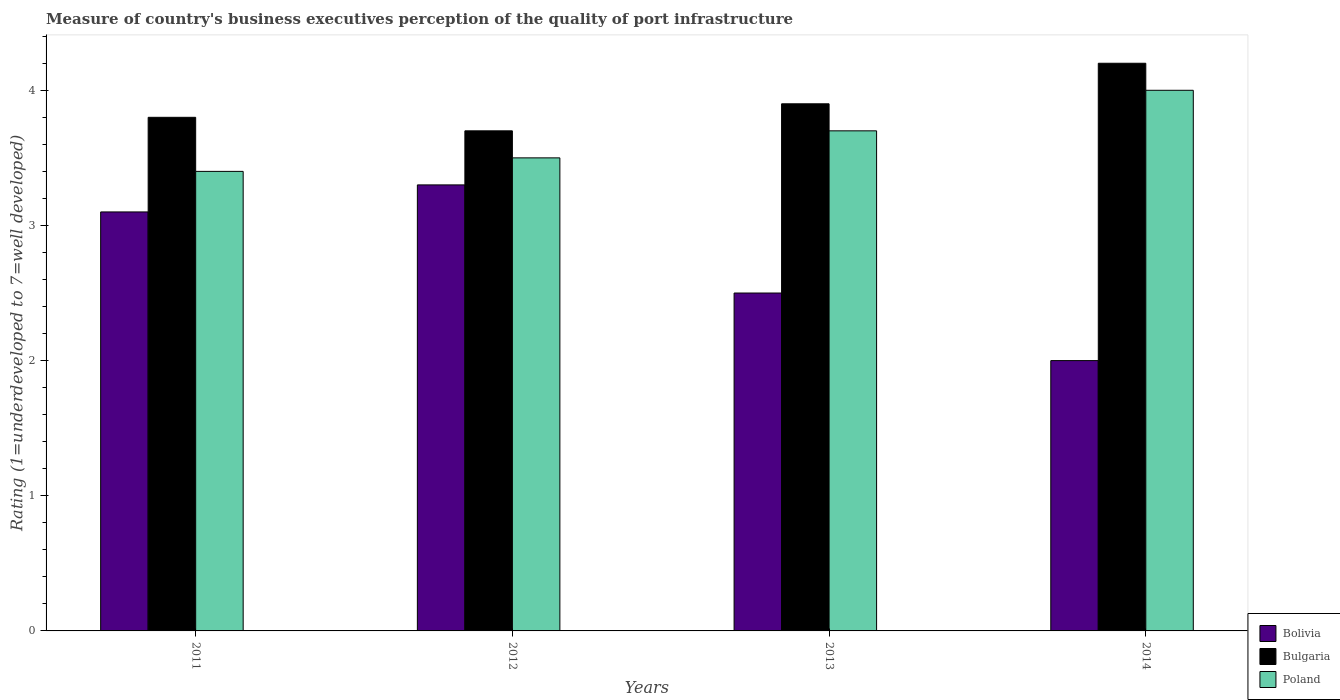How many different coloured bars are there?
Your answer should be compact. 3. In how many cases, is the number of bars for a given year not equal to the number of legend labels?
Offer a very short reply. 0. What is the ratings of the quality of port infrastructure in Bolivia in 2011?
Your answer should be compact. 3.1. Across all years, what is the maximum ratings of the quality of port infrastructure in Poland?
Your response must be concise. 4. Across all years, what is the minimum ratings of the quality of port infrastructure in Bulgaria?
Provide a short and direct response. 3.7. In which year was the ratings of the quality of port infrastructure in Poland maximum?
Offer a very short reply. 2014. What is the difference between the ratings of the quality of port infrastructure in Poland in 2012 and that in 2013?
Your response must be concise. -0.2. What is the difference between the ratings of the quality of port infrastructure in Bolivia in 2011 and the ratings of the quality of port infrastructure in Poland in 2014?
Your answer should be very brief. -0.9. What is the average ratings of the quality of port infrastructure in Bulgaria per year?
Provide a short and direct response. 3.9. In the year 2011, what is the difference between the ratings of the quality of port infrastructure in Bulgaria and ratings of the quality of port infrastructure in Poland?
Make the answer very short. 0.4. What is the difference between the highest and the second highest ratings of the quality of port infrastructure in Poland?
Your answer should be compact. 0.3. What is the difference between the highest and the lowest ratings of the quality of port infrastructure in Bolivia?
Your answer should be compact. 1.3. Is the sum of the ratings of the quality of port infrastructure in Bulgaria in 2012 and 2013 greater than the maximum ratings of the quality of port infrastructure in Poland across all years?
Ensure brevity in your answer.  Yes. What does the 2nd bar from the right in 2012 represents?
Make the answer very short. Bulgaria. Is it the case that in every year, the sum of the ratings of the quality of port infrastructure in Bolivia and ratings of the quality of port infrastructure in Bulgaria is greater than the ratings of the quality of port infrastructure in Poland?
Offer a very short reply. Yes. Are all the bars in the graph horizontal?
Give a very brief answer. No. How many years are there in the graph?
Offer a terse response. 4. What is the difference between two consecutive major ticks on the Y-axis?
Offer a very short reply. 1. How are the legend labels stacked?
Offer a terse response. Vertical. What is the title of the graph?
Your response must be concise. Measure of country's business executives perception of the quality of port infrastructure. What is the label or title of the X-axis?
Ensure brevity in your answer.  Years. What is the label or title of the Y-axis?
Ensure brevity in your answer.  Rating (1=underdeveloped to 7=well developed). What is the Rating (1=underdeveloped to 7=well developed) of Bolivia in 2011?
Your answer should be compact. 3.1. What is the Rating (1=underdeveloped to 7=well developed) in Bulgaria in 2011?
Make the answer very short. 3.8. What is the Rating (1=underdeveloped to 7=well developed) in Poland in 2012?
Your answer should be compact. 3.5. What is the Rating (1=underdeveloped to 7=well developed) in Bolivia in 2014?
Your answer should be very brief. 2. Across all years, what is the maximum Rating (1=underdeveloped to 7=well developed) in Bulgaria?
Provide a succinct answer. 4.2. Across all years, what is the maximum Rating (1=underdeveloped to 7=well developed) in Poland?
Keep it short and to the point. 4. Across all years, what is the minimum Rating (1=underdeveloped to 7=well developed) of Bolivia?
Make the answer very short. 2. Across all years, what is the minimum Rating (1=underdeveloped to 7=well developed) of Bulgaria?
Keep it short and to the point. 3.7. Across all years, what is the minimum Rating (1=underdeveloped to 7=well developed) of Poland?
Your response must be concise. 3.4. What is the total Rating (1=underdeveloped to 7=well developed) of Bolivia in the graph?
Your response must be concise. 10.9. What is the total Rating (1=underdeveloped to 7=well developed) in Poland in the graph?
Offer a terse response. 14.6. What is the difference between the Rating (1=underdeveloped to 7=well developed) of Bulgaria in 2011 and that in 2012?
Offer a very short reply. 0.1. What is the difference between the Rating (1=underdeveloped to 7=well developed) in Poland in 2011 and that in 2012?
Your answer should be very brief. -0.1. What is the difference between the Rating (1=underdeveloped to 7=well developed) of Bolivia in 2011 and that in 2013?
Your answer should be very brief. 0.6. What is the difference between the Rating (1=underdeveloped to 7=well developed) in Bolivia in 2011 and that in 2014?
Give a very brief answer. 1.1. What is the difference between the Rating (1=underdeveloped to 7=well developed) of Bulgaria in 2011 and that in 2014?
Make the answer very short. -0.4. What is the difference between the Rating (1=underdeveloped to 7=well developed) in Poland in 2012 and that in 2013?
Give a very brief answer. -0.2. What is the difference between the Rating (1=underdeveloped to 7=well developed) of Bolivia in 2012 and that in 2014?
Ensure brevity in your answer.  1.3. What is the difference between the Rating (1=underdeveloped to 7=well developed) of Poland in 2012 and that in 2014?
Offer a very short reply. -0.5. What is the difference between the Rating (1=underdeveloped to 7=well developed) of Bolivia in 2013 and that in 2014?
Provide a short and direct response. 0.5. What is the difference between the Rating (1=underdeveloped to 7=well developed) in Bulgaria in 2013 and that in 2014?
Give a very brief answer. -0.3. What is the difference between the Rating (1=underdeveloped to 7=well developed) in Bolivia in 2011 and the Rating (1=underdeveloped to 7=well developed) in Bulgaria in 2012?
Give a very brief answer. -0.6. What is the difference between the Rating (1=underdeveloped to 7=well developed) in Bolivia in 2011 and the Rating (1=underdeveloped to 7=well developed) in Poland in 2012?
Offer a terse response. -0.4. What is the difference between the Rating (1=underdeveloped to 7=well developed) in Bulgaria in 2011 and the Rating (1=underdeveloped to 7=well developed) in Poland in 2012?
Your response must be concise. 0.3. What is the difference between the Rating (1=underdeveloped to 7=well developed) of Bulgaria in 2011 and the Rating (1=underdeveloped to 7=well developed) of Poland in 2013?
Provide a short and direct response. 0.1. What is the difference between the Rating (1=underdeveloped to 7=well developed) of Bolivia in 2011 and the Rating (1=underdeveloped to 7=well developed) of Poland in 2014?
Your answer should be very brief. -0.9. What is the difference between the Rating (1=underdeveloped to 7=well developed) in Bulgaria in 2011 and the Rating (1=underdeveloped to 7=well developed) in Poland in 2014?
Give a very brief answer. -0.2. What is the difference between the Rating (1=underdeveloped to 7=well developed) of Bolivia in 2012 and the Rating (1=underdeveloped to 7=well developed) of Bulgaria in 2013?
Keep it short and to the point. -0.6. What is the difference between the Rating (1=underdeveloped to 7=well developed) in Bolivia in 2012 and the Rating (1=underdeveloped to 7=well developed) in Poland in 2014?
Your response must be concise. -0.7. What is the average Rating (1=underdeveloped to 7=well developed) in Bolivia per year?
Provide a short and direct response. 2.73. What is the average Rating (1=underdeveloped to 7=well developed) in Poland per year?
Make the answer very short. 3.65. In the year 2011, what is the difference between the Rating (1=underdeveloped to 7=well developed) of Bulgaria and Rating (1=underdeveloped to 7=well developed) of Poland?
Provide a succinct answer. 0.4. In the year 2012, what is the difference between the Rating (1=underdeveloped to 7=well developed) of Bolivia and Rating (1=underdeveloped to 7=well developed) of Poland?
Your answer should be very brief. -0.2. In the year 2013, what is the difference between the Rating (1=underdeveloped to 7=well developed) of Bolivia and Rating (1=underdeveloped to 7=well developed) of Bulgaria?
Your response must be concise. -1.4. In the year 2014, what is the difference between the Rating (1=underdeveloped to 7=well developed) of Bolivia and Rating (1=underdeveloped to 7=well developed) of Poland?
Make the answer very short. -2. What is the ratio of the Rating (1=underdeveloped to 7=well developed) in Bolivia in 2011 to that in 2012?
Give a very brief answer. 0.94. What is the ratio of the Rating (1=underdeveloped to 7=well developed) in Bulgaria in 2011 to that in 2012?
Make the answer very short. 1.03. What is the ratio of the Rating (1=underdeveloped to 7=well developed) of Poland in 2011 to that in 2012?
Keep it short and to the point. 0.97. What is the ratio of the Rating (1=underdeveloped to 7=well developed) in Bolivia in 2011 to that in 2013?
Keep it short and to the point. 1.24. What is the ratio of the Rating (1=underdeveloped to 7=well developed) in Bulgaria in 2011 to that in 2013?
Your answer should be very brief. 0.97. What is the ratio of the Rating (1=underdeveloped to 7=well developed) of Poland in 2011 to that in 2013?
Ensure brevity in your answer.  0.92. What is the ratio of the Rating (1=underdeveloped to 7=well developed) in Bolivia in 2011 to that in 2014?
Your response must be concise. 1.55. What is the ratio of the Rating (1=underdeveloped to 7=well developed) in Bulgaria in 2011 to that in 2014?
Your response must be concise. 0.9. What is the ratio of the Rating (1=underdeveloped to 7=well developed) in Bolivia in 2012 to that in 2013?
Give a very brief answer. 1.32. What is the ratio of the Rating (1=underdeveloped to 7=well developed) in Bulgaria in 2012 to that in 2013?
Keep it short and to the point. 0.95. What is the ratio of the Rating (1=underdeveloped to 7=well developed) of Poland in 2012 to that in 2013?
Give a very brief answer. 0.95. What is the ratio of the Rating (1=underdeveloped to 7=well developed) of Bolivia in 2012 to that in 2014?
Provide a short and direct response. 1.65. What is the ratio of the Rating (1=underdeveloped to 7=well developed) in Bulgaria in 2012 to that in 2014?
Give a very brief answer. 0.88. What is the ratio of the Rating (1=underdeveloped to 7=well developed) in Bolivia in 2013 to that in 2014?
Your answer should be very brief. 1.25. What is the ratio of the Rating (1=underdeveloped to 7=well developed) in Poland in 2013 to that in 2014?
Offer a terse response. 0.93. What is the difference between the highest and the second highest Rating (1=underdeveloped to 7=well developed) in Bolivia?
Give a very brief answer. 0.2. What is the difference between the highest and the second highest Rating (1=underdeveloped to 7=well developed) of Bulgaria?
Your response must be concise. 0.3. What is the difference between the highest and the second highest Rating (1=underdeveloped to 7=well developed) in Poland?
Offer a terse response. 0.3. What is the difference between the highest and the lowest Rating (1=underdeveloped to 7=well developed) of Poland?
Offer a very short reply. 0.6. 